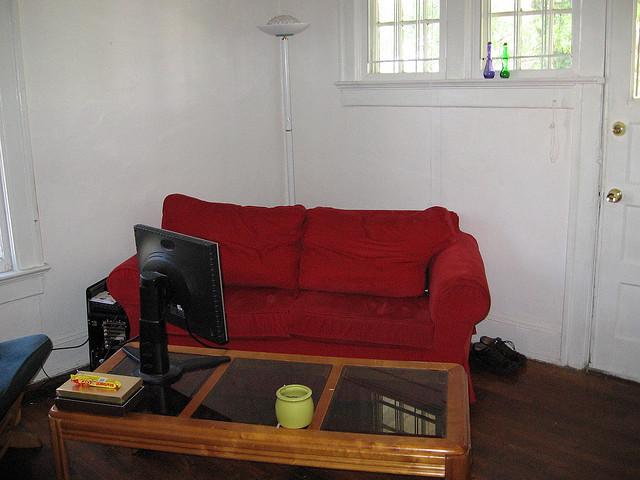What color is the couch?
Be succinct. Red. How many shoes are by the couch?
Answer briefly. 2. Is the door open?
Be succinct. No. What color are the walls?
Answer briefly. White. Are the walls decorated?
Write a very short answer. No. What shape are pillows showing?
Quick response, please. Rectangle. What color is the door?
Give a very brief answer. White. 